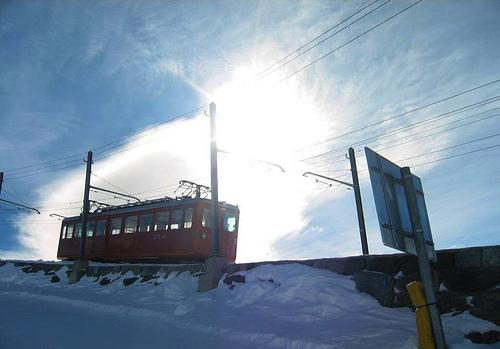Identify the primary mode of transportation in the image. A red trolley train is the primary mode of transportation on a track. What is the color of the object attached to the sign post? The object attached to the sign post is orange. What type of weather can be observed in the image? Cloudy with patches of sunlight shining through. Mention an element in the image connected to the electrical infrastructure. Utility pole by the tracks with electrical wires above them. In an expressive manner, describe the interplay of sunlight and clouds in the sky. The sunlight gracefully pierces through the scattering clouds, casting a warm and slightly mystical glow upon the scene below. Calculate the number of windows on the side of the train. There are several windows on the side of the train, visible through its glass panels. Explain the overall scene of the image in a sentence. A red tram car travels on a snowy track, under a cloudy sky with sunlight breaking through. List three prominent features in the image. Red tram car on the tracks, snow-covered ground, electrical wires above tracks. Estimate the ratio of ground covered in snow to the total area of the image. Approximately two-thirds of the ground is covered in snow. Provide a brief description of the environment the red tram is passing through. The red tram car is traveling through a wintry landscape with snow-covered ground, utility poles, and boulders beside the tracks. What is the main object found in the image? trolley train on a track Is there light behind the tram? yes, bright light is behind the tram Describe the light condition in the scene. sunlight shining through scattered clouds Identify an object that is not a part of the train. boulder in the snow Describe the weather as seen in the image. cloudy with sunlight shining through clouds Is the trolley train on the track green in color? The trolley train is actually red, not green. Describe the utility pole by the tram tracks. a pole with electric lines and lights Which object is seen above the trolley train? electrical wires What's the color of the sky above the train? bright blue Are there people visible inside the windows on the side of the train? The windows show a red tram car with no passengers. Describe the scene that contains the train. red tram car with no passengers on a track surrounded by snow with clouds in the sky What physical features are found on the train in the image? windows, white letters, and side edges Is the text on the back of the sign clearly visible and legible? No, it's not mentioned in the image. What color is the tram car, and how many windows does it have? the tram car is red and has many windows What is attached to the metal sign pole in the scene? yellow pole and orange object Can you see a little girl playing in the snow on the ground? There is no mention of any person in the image, only white snow on the ground is described. List five objects found in the image. trolley train, clouds, snow, sign, utility pole What kind of ground is the train on? ground covered in snow What does the sign beside the tracks look like? white sign on a metal pole attached to a yellow pole Explain the relationship between the electrical wires and the train. the electric tram car wires are connected to poles above the train What kind of cumulus formation can be observed in the scene? scattered clouds in a blue sky List the objects found beside the train tracks. utility pole, sign, boulders, snow, electrical wires What kind of object is seen along the side of the tram car? a row of glass windows 